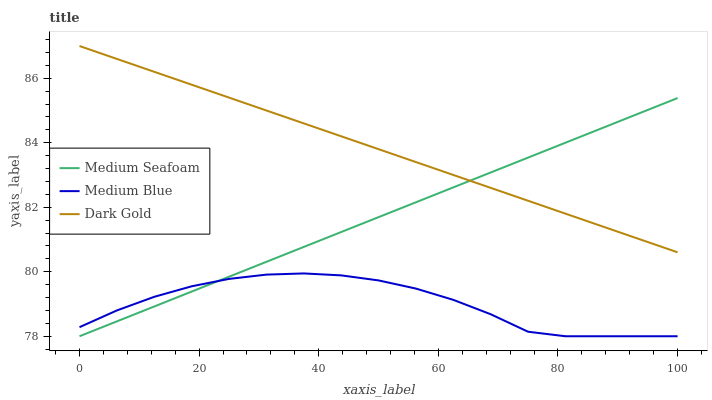Does Medium Blue have the minimum area under the curve?
Answer yes or no. Yes. Does Dark Gold have the maximum area under the curve?
Answer yes or no. Yes. Does Medium Seafoam have the minimum area under the curve?
Answer yes or no. No. Does Medium Seafoam have the maximum area under the curve?
Answer yes or no. No. Is Dark Gold the smoothest?
Answer yes or no. Yes. Is Medium Blue the roughest?
Answer yes or no. Yes. Is Medium Seafoam the smoothest?
Answer yes or no. No. Is Medium Seafoam the roughest?
Answer yes or no. No. Does Dark Gold have the lowest value?
Answer yes or no. No. Does Dark Gold have the highest value?
Answer yes or no. Yes. Does Medium Seafoam have the highest value?
Answer yes or no. No. Is Medium Blue less than Dark Gold?
Answer yes or no. Yes. Is Dark Gold greater than Medium Blue?
Answer yes or no. Yes. Does Dark Gold intersect Medium Seafoam?
Answer yes or no. Yes. Is Dark Gold less than Medium Seafoam?
Answer yes or no. No. Is Dark Gold greater than Medium Seafoam?
Answer yes or no. No. Does Medium Blue intersect Dark Gold?
Answer yes or no. No. 